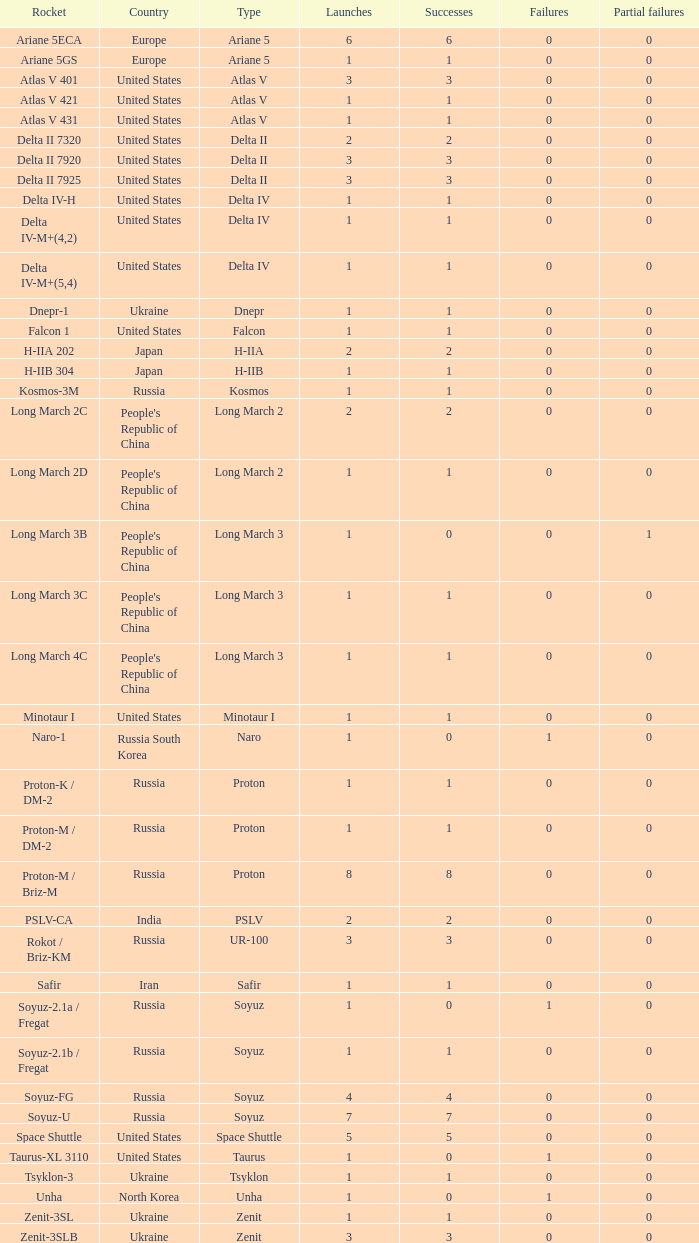What's the total failures among rockets that had more than 3 successes, type ariane 5 and more than 0 partial failures? 0.0. 